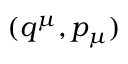<formula> <loc_0><loc_0><loc_500><loc_500>( q ^ { \mu } , p _ { \mu } )</formula> 